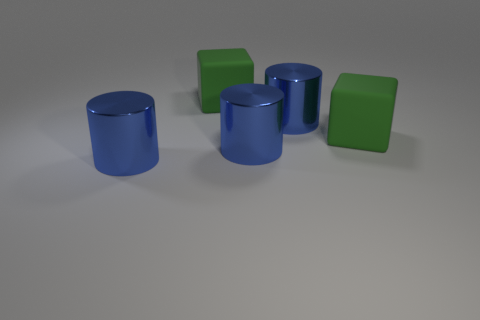Add 3 matte cubes. How many objects exist? 8 Subtract 1 cylinders. How many cylinders are left? 2 Add 4 cylinders. How many cylinders exist? 7 Subtract 0 red cylinders. How many objects are left? 5 Subtract all cylinders. How many objects are left? 2 Subtract all red cylinders. Subtract all purple cubes. How many cylinders are left? 3 Subtract all rubber objects. Subtract all big green rubber cubes. How many objects are left? 1 Add 2 green rubber cubes. How many green rubber cubes are left? 4 